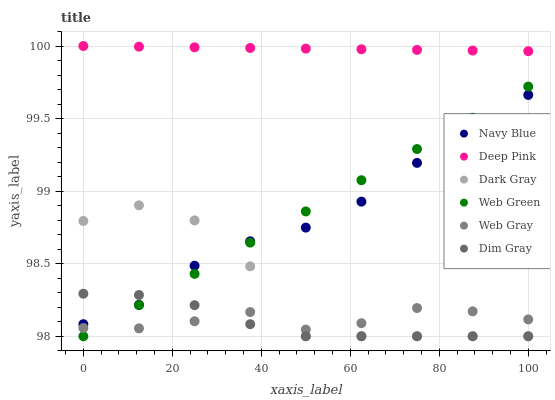Does Dim Gray have the minimum area under the curve?
Answer yes or no. Yes. Does Deep Pink have the maximum area under the curve?
Answer yes or no. Yes. Does Navy Blue have the minimum area under the curve?
Answer yes or no. No. Does Navy Blue have the maximum area under the curve?
Answer yes or no. No. Is Web Green the smoothest?
Answer yes or no. Yes. Is Dark Gray the roughest?
Answer yes or no. Yes. Is Navy Blue the smoothest?
Answer yes or no. No. Is Navy Blue the roughest?
Answer yes or no. No. Does Dim Gray have the lowest value?
Answer yes or no. Yes. Does Navy Blue have the lowest value?
Answer yes or no. No. Does Deep Pink have the highest value?
Answer yes or no. Yes. Does Navy Blue have the highest value?
Answer yes or no. No. Is Web Gray less than Deep Pink?
Answer yes or no. Yes. Is Deep Pink greater than Web Gray?
Answer yes or no. Yes. Does Web Gray intersect Web Green?
Answer yes or no. Yes. Is Web Gray less than Web Green?
Answer yes or no. No. Is Web Gray greater than Web Green?
Answer yes or no. No. Does Web Gray intersect Deep Pink?
Answer yes or no. No. 